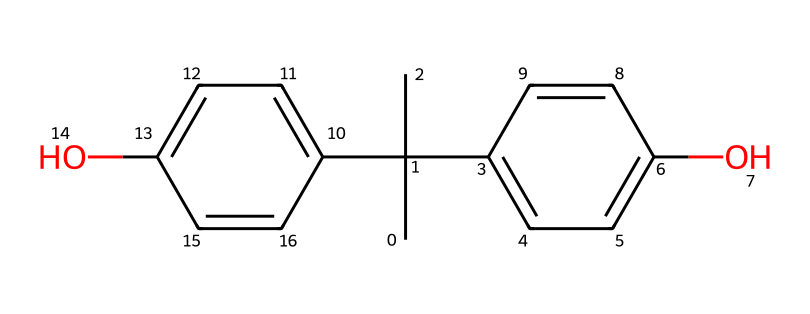What is the main functional group present in BPA? The chemical structure shows hydroxyl (-OH) groups attached to aromatic rings, which are characteristic of phenolic compounds.
Answer: hydroxyl How many carbon atoms are in BPA? By analyzing the SMILES representation, there are 15 carbon atoms present in the structure.
Answer: 15 What type of chemical bonding is primarily present in BPA's structure? The structure contains predominantly covalent bonds between carbon and hydrogen atoms, as well as in carbon-carbon bonds.
Answer: covalent How many aromatic rings are in the structure of BPA? The chemical features two distinct aromatic rings, one on each side of the central carbon bridge.
Answer: 2 What is the total number of hydroxyl groups in BPA? The structure indicates two -OH functional groups attached to the aromatic rings, which count as hydroxyl groups.
Answer: 2 Is BPA classified as a monomer or a polymer? BPA is primarily classified as a monomer since it acts as a building block in the synthesis of polycarbonate plastics and epoxy resins.
Answer: monomer Which property of BPA might raise health and safety concerns? The presence of hydroxyl groups indicates that BPA can mimic estrogen, potentially leading to endocrine disruption, which raises health and safety concerns.
Answer: endocrine disruptor 